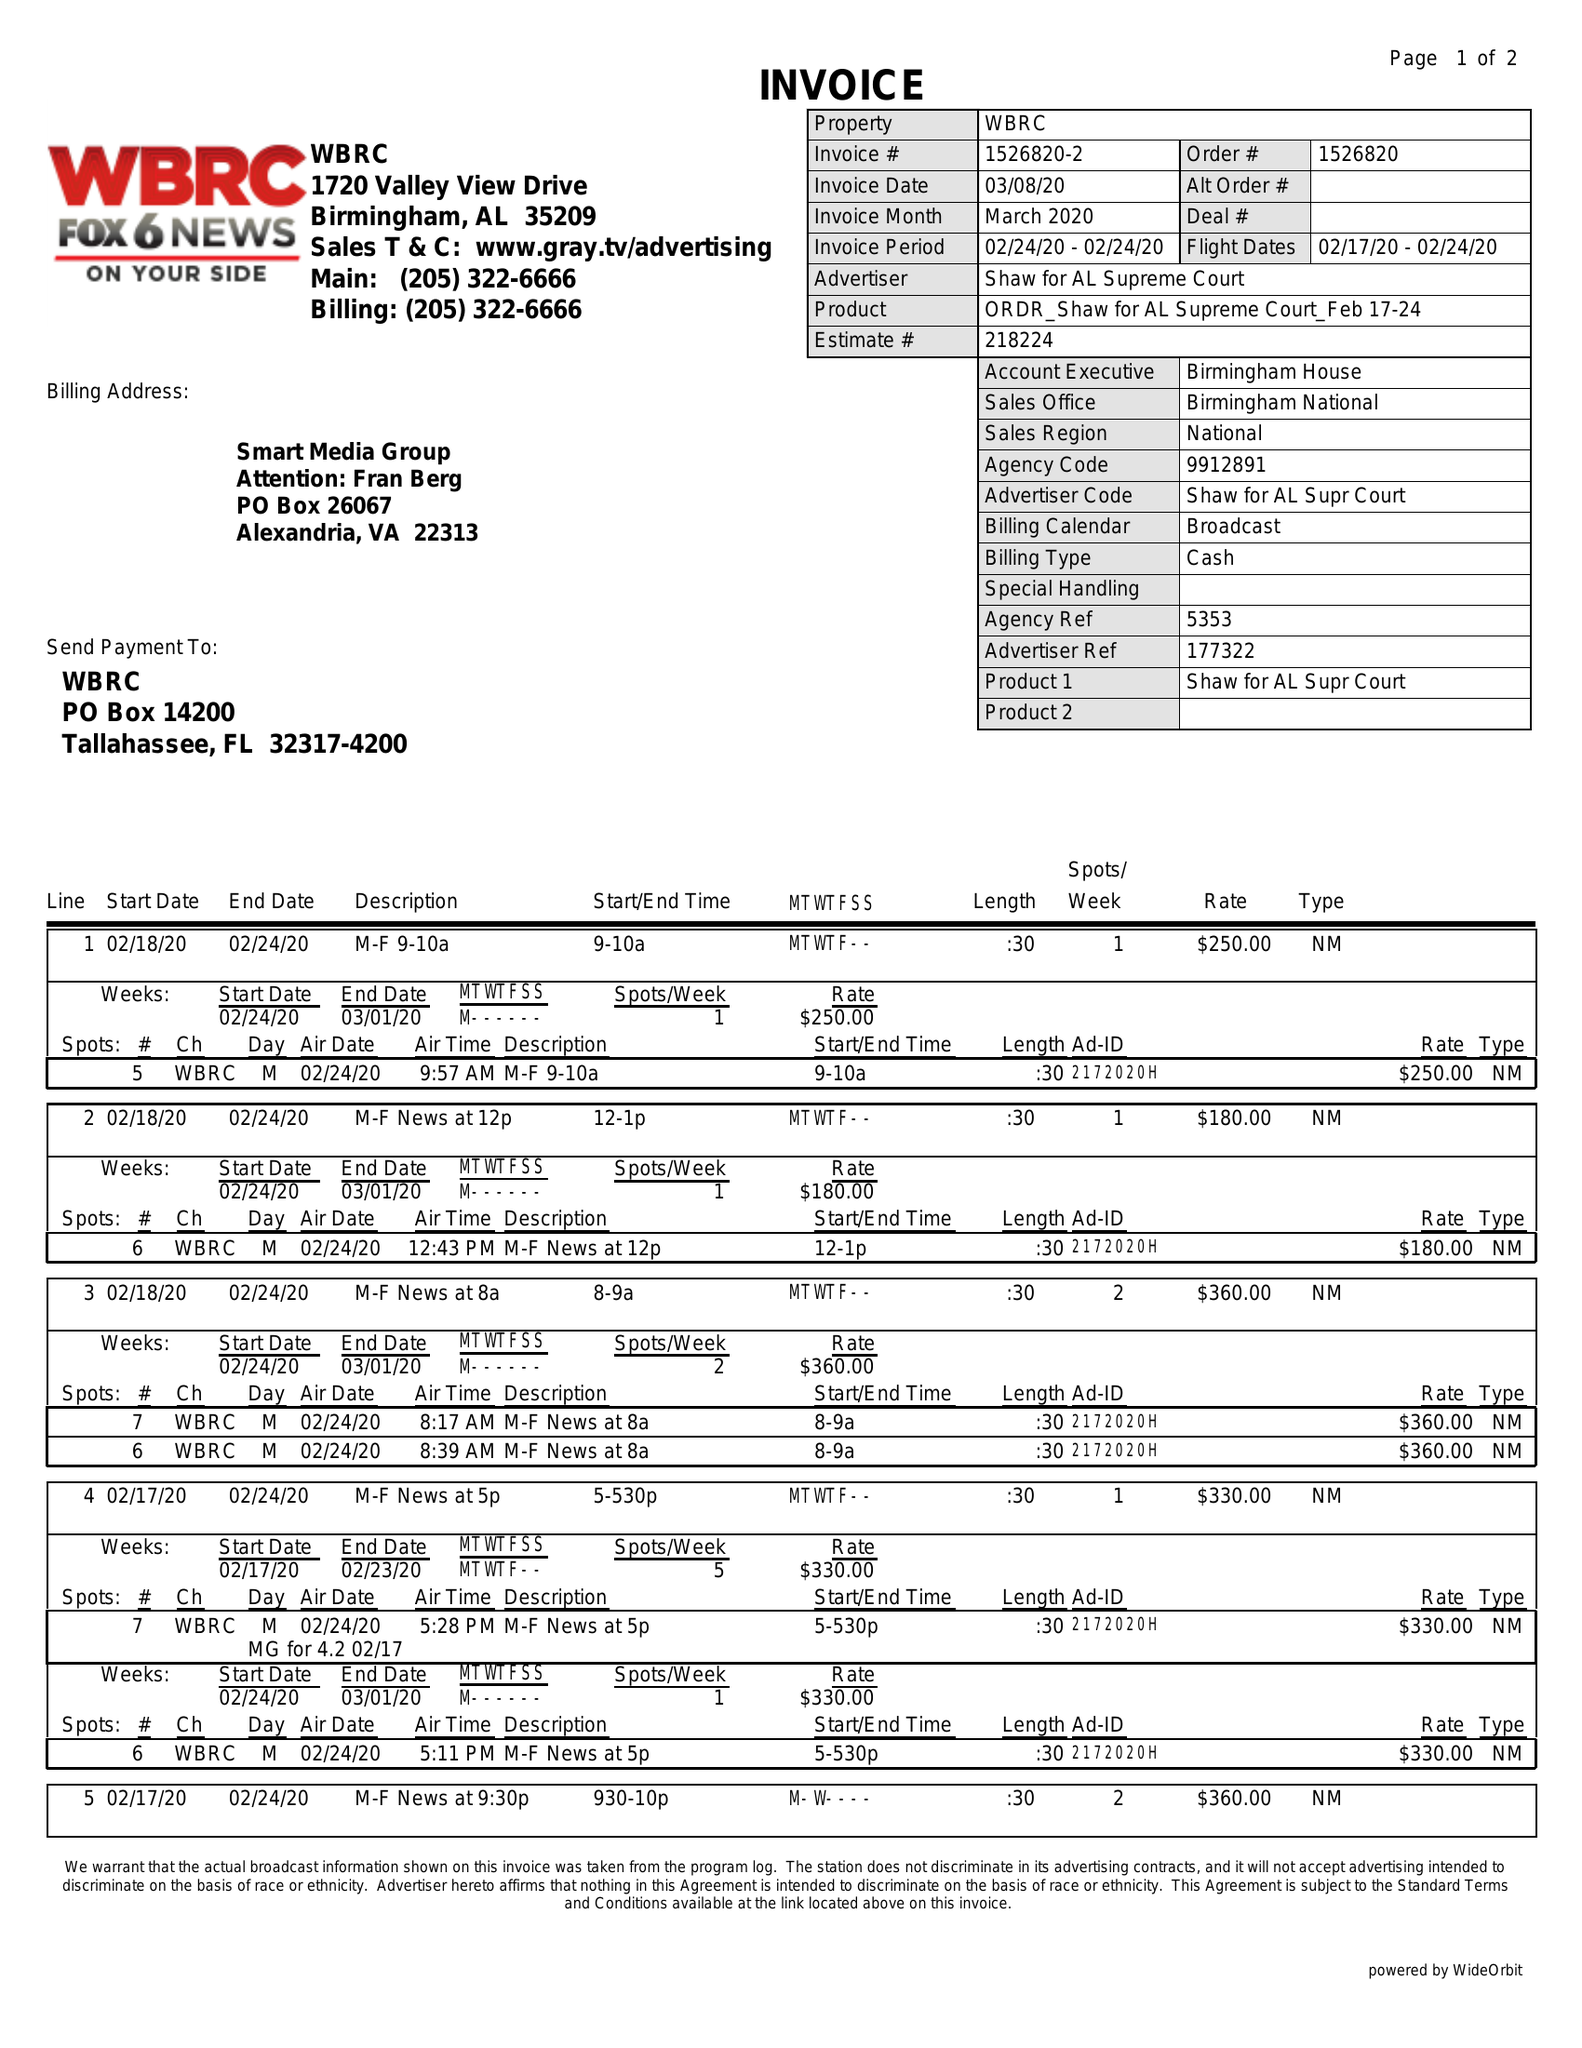What is the value for the contract_num?
Answer the question using a single word or phrase. 1526820 